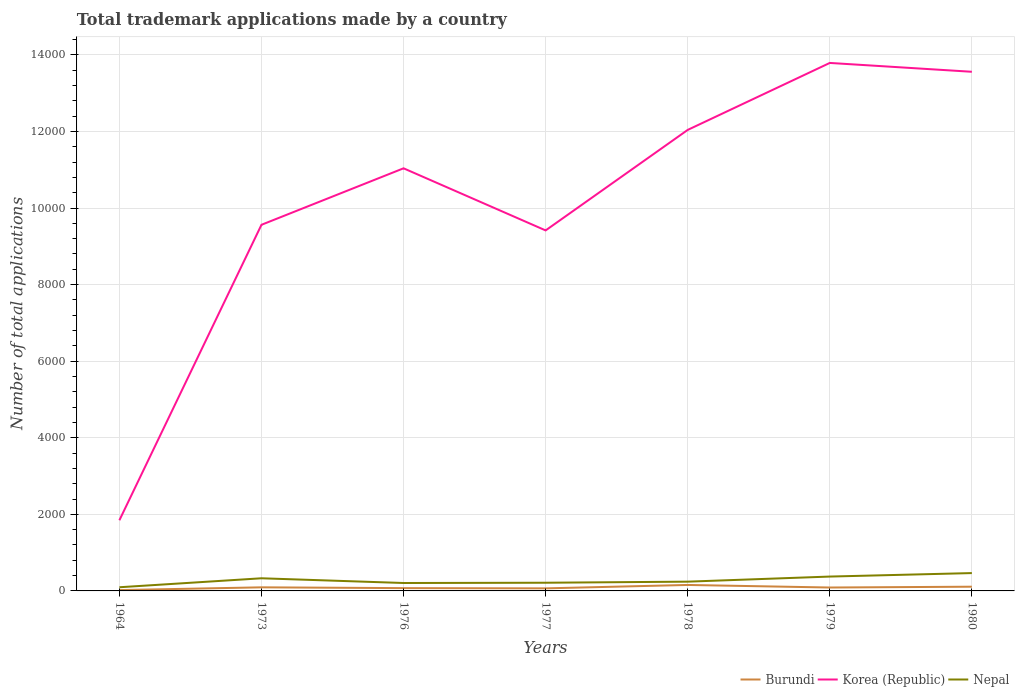How many different coloured lines are there?
Ensure brevity in your answer.  3. Across all years, what is the maximum number of applications made by in Korea (Republic)?
Offer a terse response. 1845. In which year was the number of applications made by in Nepal maximum?
Offer a terse response. 1964. What is the total number of applications made by in Korea (Republic) in the graph?
Give a very brief answer. -2478. What is the difference between the highest and the second highest number of applications made by in Korea (Republic)?
Give a very brief answer. 1.19e+04. What is the difference between the highest and the lowest number of applications made by in Nepal?
Provide a short and direct response. 3. Is the number of applications made by in Nepal strictly greater than the number of applications made by in Burundi over the years?
Provide a succinct answer. No. How many years are there in the graph?
Your answer should be compact. 7. How are the legend labels stacked?
Offer a very short reply. Horizontal. What is the title of the graph?
Give a very brief answer. Total trademark applications made by a country. What is the label or title of the X-axis?
Make the answer very short. Years. What is the label or title of the Y-axis?
Keep it short and to the point. Number of total applications. What is the Number of total applications of Burundi in 1964?
Keep it short and to the point. 22. What is the Number of total applications in Korea (Republic) in 1964?
Keep it short and to the point. 1845. What is the Number of total applications in Nepal in 1964?
Your answer should be compact. 96. What is the Number of total applications in Burundi in 1973?
Make the answer very short. 94. What is the Number of total applications of Korea (Republic) in 1973?
Provide a short and direct response. 9562. What is the Number of total applications in Nepal in 1973?
Provide a short and direct response. 330. What is the Number of total applications in Korea (Republic) in 1976?
Offer a very short reply. 1.10e+04. What is the Number of total applications of Nepal in 1976?
Offer a terse response. 207. What is the Number of total applications of Burundi in 1977?
Provide a short and direct response. 67. What is the Number of total applications of Korea (Republic) in 1977?
Your answer should be very brief. 9415. What is the Number of total applications in Nepal in 1977?
Ensure brevity in your answer.  214. What is the Number of total applications in Burundi in 1978?
Your response must be concise. 156. What is the Number of total applications of Korea (Republic) in 1978?
Provide a short and direct response. 1.20e+04. What is the Number of total applications in Nepal in 1978?
Give a very brief answer. 242. What is the Number of total applications of Burundi in 1979?
Provide a short and direct response. 89. What is the Number of total applications in Korea (Republic) in 1979?
Make the answer very short. 1.38e+04. What is the Number of total applications in Nepal in 1979?
Your answer should be compact. 375. What is the Number of total applications of Burundi in 1980?
Give a very brief answer. 110. What is the Number of total applications of Korea (Republic) in 1980?
Keep it short and to the point. 1.36e+04. What is the Number of total applications in Nepal in 1980?
Ensure brevity in your answer.  466. Across all years, what is the maximum Number of total applications of Burundi?
Your answer should be compact. 156. Across all years, what is the maximum Number of total applications in Korea (Republic)?
Provide a short and direct response. 1.38e+04. Across all years, what is the maximum Number of total applications of Nepal?
Your answer should be very brief. 466. Across all years, what is the minimum Number of total applications in Korea (Republic)?
Make the answer very short. 1845. Across all years, what is the minimum Number of total applications in Nepal?
Keep it short and to the point. 96. What is the total Number of total applications in Burundi in the graph?
Provide a succinct answer. 611. What is the total Number of total applications of Korea (Republic) in the graph?
Your answer should be very brief. 7.12e+04. What is the total Number of total applications of Nepal in the graph?
Provide a succinct answer. 1930. What is the difference between the Number of total applications of Burundi in 1964 and that in 1973?
Your response must be concise. -72. What is the difference between the Number of total applications in Korea (Republic) in 1964 and that in 1973?
Your response must be concise. -7717. What is the difference between the Number of total applications in Nepal in 1964 and that in 1973?
Keep it short and to the point. -234. What is the difference between the Number of total applications in Burundi in 1964 and that in 1976?
Give a very brief answer. -51. What is the difference between the Number of total applications in Korea (Republic) in 1964 and that in 1976?
Provide a short and direct response. -9192. What is the difference between the Number of total applications of Nepal in 1964 and that in 1976?
Your answer should be compact. -111. What is the difference between the Number of total applications in Burundi in 1964 and that in 1977?
Make the answer very short. -45. What is the difference between the Number of total applications in Korea (Republic) in 1964 and that in 1977?
Offer a very short reply. -7570. What is the difference between the Number of total applications of Nepal in 1964 and that in 1977?
Offer a terse response. -118. What is the difference between the Number of total applications of Burundi in 1964 and that in 1978?
Offer a terse response. -134. What is the difference between the Number of total applications in Korea (Republic) in 1964 and that in 1978?
Your answer should be very brief. -1.02e+04. What is the difference between the Number of total applications of Nepal in 1964 and that in 1978?
Your response must be concise. -146. What is the difference between the Number of total applications in Burundi in 1964 and that in 1979?
Provide a short and direct response. -67. What is the difference between the Number of total applications in Korea (Republic) in 1964 and that in 1979?
Your answer should be very brief. -1.19e+04. What is the difference between the Number of total applications of Nepal in 1964 and that in 1979?
Give a very brief answer. -279. What is the difference between the Number of total applications of Burundi in 1964 and that in 1980?
Your answer should be very brief. -88. What is the difference between the Number of total applications of Korea (Republic) in 1964 and that in 1980?
Your answer should be compact. -1.17e+04. What is the difference between the Number of total applications in Nepal in 1964 and that in 1980?
Your answer should be compact. -370. What is the difference between the Number of total applications of Burundi in 1973 and that in 1976?
Offer a terse response. 21. What is the difference between the Number of total applications of Korea (Republic) in 1973 and that in 1976?
Keep it short and to the point. -1475. What is the difference between the Number of total applications in Nepal in 1973 and that in 1976?
Your answer should be compact. 123. What is the difference between the Number of total applications in Korea (Republic) in 1973 and that in 1977?
Give a very brief answer. 147. What is the difference between the Number of total applications in Nepal in 1973 and that in 1977?
Your answer should be compact. 116. What is the difference between the Number of total applications of Burundi in 1973 and that in 1978?
Offer a terse response. -62. What is the difference between the Number of total applications of Korea (Republic) in 1973 and that in 1978?
Your response must be concise. -2478. What is the difference between the Number of total applications in Nepal in 1973 and that in 1978?
Keep it short and to the point. 88. What is the difference between the Number of total applications in Korea (Republic) in 1973 and that in 1979?
Your response must be concise. -4227. What is the difference between the Number of total applications of Nepal in 1973 and that in 1979?
Give a very brief answer. -45. What is the difference between the Number of total applications in Korea (Republic) in 1973 and that in 1980?
Keep it short and to the point. -3996. What is the difference between the Number of total applications in Nepal in 1973 and that in 1980?
Ensure brevity in your answer.  -136. What is the difference between the Number of total applications of Burundi in 1976 and that in 1977?
Make the answer very short. 6. What is the difference between the Number of total applications in Korea (Republic) in 1976 and that in 1977?
Provide a succinct answer. 1622. What is the difference between the Number of total applications of Burundi in 1976 and that in 1978?
Make the answer very short. -83. What is the difference between the Number of total applications in Korea (Republic) in 1976 and that in 1978?
Give a very brief answer. -1003. What is the difference between the Number of total applications in Nepal in 1976 and that in 1978?
Provide a succinct answer. -35. What is the difference between the Number of total applications of Burundi in 1976 and that in 1979?
Your response must be concise. -16. What is the difference between the Number of total applications in Korea (Republic) in 1976 and that in 1979?
Make the answer very short. -2752. What is the difference between the Number of total applications in Nepal in 1976 and that in 1979?
Provide a succinct answer. -168. What is the difference between the Number of total applications in Burundi in 1976 and that in 1980?
Offer a terse response. -37. What is the difference between the Number of total applications in Korea (Republic) in 1976 and that in 1980?
Keep it short and to the point. -2521. What is the difference between the Number of total applications of Nepal in 1976 and that in 1980?
Make the answer very short. -259. What is the difference between the Number of total applications in Burundi in 1977 and that in 1978?
Provide a short and direct response. -89. What is the difference between the Number of total applications of Korea (Republic) in 1977 and that in 1978?
Your answer should be compact. -2625. What is the difference between the Number of total applications in Burundi in 1977 and that in 1979?
Offer a very short reply. -22. What is the difference between the Number of total applications in Korea (Republic) in 1977 and that in 1979?
Your response must be concise. -4374. What is the difference between the Number of total applications in Nepal in 1977 and that in 1979?
Offer a very short reply. -161. What is the difference between the Number of total applications of Burundi in 1977 and that in 1980?
Offer a terse response. -43. What is the difference between the Number of total applications in Korea (Republic) in 1977 and that in 1980?
Provide a short and direct response. -4143. What is the difference between the Number of total applications in Nepal in 1977 and that in 1980?
Your answer should be very brief. -252. What is the difference between the Number of total applications in Burundi in 1978 and that in 1979?
Your response must be concise. 67. What is the difference between the Number of total applications of Korea (Republic) in 1978 and that in 1979?
Your response must be concise. -1749. What is the difference between the Number of total applications in Nepal in 1978 and that in 1979?
Your answer should be very brief. -133. What is the difference between the Number of total applications of Burundi in 1978 and that in 1980?
Offer a terse response. 46. What is the difference between the Number of total applications in Korea (Republic) in 1978 and that in 1980?
Give a very brief answer. -1518. What is the difference between the Number of total applications of Nepal in 1978 and that in 1980?
Your response must be concise. -224. What is the difference between the Number of total applications of Burundi in 1979 and that in 1980?
Your answer should be very brief. -21. What is the difference between the Number of total applications of Korea (Republic) in 1979 and that in 1980?
Your answer should be compact. 231. What is the difference between the Number of total applications in Nepal in 1979 and that in 1980?
Give a very brief answer. -91. What is the difference between the Number of total applications in Burundi in 1964 and the Number of total applications in Korea (Republic) in 1973?
Your answer should be very brief. -9540. What is the difference between the Number of total applications in Burundi in 1964 and the Number of total applications in Nepal in 1973?
Your answer should be very brief. -308. What is the difference between the Number of total applications in Korea (Republic) in 1964 and the Number of total applications in Nepal in 1973?
Your response must be concise. 1515. What is the difference between the Number of total applications of Burundi in 1964 and the Number of total applications of Korea (Republic) in 1976?
Keep it short and to the point. -1.10e+04. What is the difference between the Number of total applications of Burundi in 1964 and the Number of total applications of Nepal in 1976?
Make the answer very short. -185. What is the difference between the Number of total applications in Korea (Republic) in 1964 and the Number of total applications in Nepal in 1976?
Make the answer very short. 1638. What is the difference between the Number of total applications of Burundi in 1964 and the Number of total applications of Korea (Republic) in 1977?
Offer a very short reply. -9393. What is the difference between the Number of total applications in Burundi in 1964 and the Number of total applications in Nepal in 1977?
Your answer should be compact. -192. What is the difference between the Number of total applications of Korea (Republic) in 1964 and the Number of total applications of Nepal in 1977?
Your answer should be very brief. 1631. What is the difference between the Number of total applications in Burundi in 1964 and the Number of total applications in Korea (Republic) in 1978?
Your answer should be compact. -1.20e+04. What is the difference between the Number of total applications in Burundi in 1964 and the Number of total applications in Nepal in 1978?
Provide a succinct answer. -220. What is the difference between the Number of total applications in Korea (Republic) in 1964 and the Number of total applications in Nepal in 1978?
Provide a succinct answer. 1603. What is the difference between the Number of total applications of Burundi in 1964 and the Number of total applications of Korea (Republic) in 1979?
Make the answer very short. -1.38e+04. What is the difference between the Number of total applications in Burundi in 1964 and the Number of total applications in Nepal in 1979?
Offer a very short reply. -353. What is the difference between the Number of total applications of Korea (Republic) in 1964 and the Number of total applications of Nepal in 1979?
Ensure brevity in your answer.  1470. What is the difference between the Number of total applications of Burundi in 1964 and the Number of total applications of Korea (Republic) in 1980?
Your answer should be very brief. -1.35e+04. What is the difference between the Number of total applications of Burundi in 1964 and the Number of total applications of Nepal in 1980?
Your response must be concise. -444. What is the difference between the Number of total applications in Korea (Republic) in 1964 and the Number of total applications in Nepal in 1980?
Provide a short and direct response. 1379. What is the difference between the Number of total applications of Burundi in 1973 and the Number of total applications of Korea (Republic) in 1976?
Keep it short and to the point. -1.09e+04. What is the difference between the Number of total applications in Burundi in 1973 and the Number of total applications in Nepal in 1976?
Provide a succinct answer. -113. What is the difference between the Number of total applications of Korea (Republic) in 1973 and the Number of total applications of Nepal in 1976?
Your answer should be compact. 9355. What is the difference between the Number of total applications of Burundi in 1973 and the Number of total applications of Korea (Republic) in 1977?
Your answer should be very brief. -9321. What is the difference between the Number of total applications in Burundi in 1973 and the Number of total applications in Nepal in 1977?
Your answer should be compact. -120. What is the difference between the Number of total applications of Korea (Republic) in 1973 and the Number of total applications of Nepal in 1977?
Provide a short and direct response. 9348. What is the difference between the Number of total applications in Burundi in 1973 and the Number of total applications in Korea (Republic) in 1978?
Your answer should be compact. -1.19e+04. What is the difference between the Number of total applications of Burundi in 1973 and the Number of total applications of Nepal in 1978?
Provide a succinct answer. -148. What is the difference between the Number of total applications in Korea (Republic) in 1973 and the Number of total applications in Nepal in 1978?
Provide a succinct answer. 9320. What is the difference between the Number of total applications in Burundi in 1973 and the Number of total applications in Korea (Republic) in 1979?
Your answer should be very brief. -1.37e+04. What is the difference between the Number of total applications in Burundi in 1973 and the Number of total applications in Nepal in 1979?
Your response must be concise. -281. What is the difference between the Number of total applications in Korea (Republic) in 1973 and the Number of total applications in Nepal in 1979?
Ensure brevity in your answer.  9187. What is the difference between the Number of total applications in Burundi in 1973 and the Number of total applications in Korea (Republic) in 1980?
Ensure brevity in your answer.  -1.35e+04. What is the difference between the Number of total applications of Burundi in 1973 and the Number of total applications of Nepal in 1980?
Ensure brevity in your answer.  -372. What is the difference between the Number of total applications of Korea (Republic) in 1973 and the Number of total applications of Nepal in 1980?
Make the answer very short. 9096. What is the difference between the Number of total applications in Burundi in 1976 and the Number of total applications in Korea (Republic) in 1977?
Provide a succinct answer. -9342. What is the difference between the Number of total applications in Burundi in 1976 and the Number of total applications in Nepal in 1977?
Your answer should be very brief. -141. What is the difference between the Number of total applications in Korea (Republic) in 1976 and the Number of total applications in Nepal in 1977?
Give a very brief answer. 1.08e+04. What is the difference between the Number of total applications of Burundi in 1976 and the Number of total applications of Korea (Republic) in 1978?
Provide a succinct answer. -1.20e+04. What is the difference between the Number of total applications in Burundi in 1976 and the Number of total applications in Nepal in 1978?
Provide a succinct answer. -169. What is the difference between the Number of total applications of Korea (Republic) in 1976 and the Number of total applications of Nepal in 1978?
Give a very brief answer. 1.08e+04. What is the difference between the Number of total applications of Burundi in 1976 and the Number of total applications of Korea (Republic) in 1979?
Keep it short and to the point. -1.37e+04. What is the difference between the Number of total applications of Burundi in 1976 and the Number of total applications of Nepal in 1979?
Provide a succinct answer. -302. What is the difference between the Number of total applications of Korea (Republic) in 1976 and the Number of total applications of Nepal in 1979?
Offer a very short reply. 1.07e+04. What is the difference between the Number of total applications of Burundi in 1976 and the Number of total applications of Korea (Republic) in 1980?
Your answer should be compact. -1.35e+04. What is the difference between the Number of total applications in Burundi in 1976 and the Number of total applications in Nepal in 1980?
Make the answer very short. -393. What is the difference between the Number of total applications in Korea (Republic) in 1976 and the Number of total applications in Nepal in 1980?
Provide a succinct answer. 1.06e+04. What is the difference between the Number of total applications in Burundi in 1977 and the Number of total applications in Korea (Republic) in 1978?
Your response must be concise. -1.20e+04. What is the difference between the Number of total applications in Burundi in 1977 and the Number of total applications in Nepal in 1978?
Your response must be concise. -175. What is the difference between the Number of total applications in Korea (Republic) in 1977 and the Number of total applications in Nepal in 1978?
Offer a terse response. 9173. What is the difference between the Number of total applications in Burundi in 1977 and the Number of total applications in Korea (Republic) in 1979?
Make the answer very short. -1.37e+04. What is the difference between the Number of total applications in Burundi in 1977 and the Number of total applications in Nepal in 1979?
Your response must be concise. -308. What is the difference between the Number of total applications in Korea (Republic) in 1977 and the Number of total applications in Nepal in 1979?
Give a very brief answer. 9040. What is the difference between the Number of total applications in Burundi in 1977 and the Number of total applications in Korea (Republic) in 1980?
Offer a very short reply. -1.35e+04. What is the difference between the Number of total applications in Burundi in 1977 and the Number of total applications in Nepal in 1980?
Give a very brief answer. -399. What is the difference between the Number of total applications of Korea (Republic) in 1977 and the Number of total applications of Nepal in 1980?
Offer a terse response. 8949. What is the difference between the Number of total applications in Burundi in 1978 and the Number of total applications in Korea (Republic) in 1979?
Ensure brevity in your answer.  -1.36e+04. What is the difference between the Number of total applications of Burundi in 1978 and the Number of total applications of Nepal in 1979?
Your response must be concise. -219. What is the difference between the Number of total applications of Korea (Republic) in 1978 and the Number of total applications of Nepal in 1979?
Give a very brief answer. 1.17e+04. What is the difference between the Number of total applications in Burundi in 1978 and the Number of total applications in Korea (Republic) in 1980?
Your answer should be very brief. -1.34e+04. What is the difference between the Number of total applications in Burundi in 1978 and the Number of total applications in Nepal in 1980?
Your answer should be very brief. -310. What is the difference between the Number of total applications in Korea (Republic) in 1978 and the Number of total applications in Nepal in 1980?
Your answer should be very brief. 1.16e+04. What is the difference between the Number of total applications of Burundi in 1979 and the Number of total applications of Korea (Republic) in 1980?
Keep it short and to the point. -1.35e+04. What is the difference between the Number of total applications in Burundi in 1979 and the Number of total applications in Nepal in 1980?
Offer a very short reply. -377. What is the difference between the Number of total applications of Korea (Republic) in 1979 and the Number of total applications of Nepal in 1980?
Ensure brevity in your answer.  1.33e+04. What is the average Number of total applications in Burundi per year?
Your response must be concise. 87.29. What is the average Number of total applications of Korea (Republic) per year?
Your answer should be compact. 1.02e+04. What is the average Number of total applications of Nepal per year?
Your response must be concise. 275.71. In the year 1964, what is the difference between the Number of total applications of Burundi and Number of total applications of Korea (Republic)?
Your answer should be very brief. -1823. In the year 1964, what is the difference between the Number of total applications in Burundi and Number of total applications in Nepal?
Make the answer very short. -74. In the year 1964, what is the difference between the Number of total applications of Korea (Republic) and Number of total applications of Nepal?
Your answer should be very brief. 1749. In the year 1973, what is the difference between the Number of total applications in Burundi and Number of total applications in Korea (Republic)?
Provide a short and direct response. -9468. In the year 1973, what is the difference between the Number of total applications of Burundi and Number of total applications of Nepal?
Provide a short and direct response. -236. In the year 1973, what is the difference between the Number of total applications of Korea (Republic) and Number of total applications of Nepal?
Ensure brevity in your answer.  9232. In the year 1976, what is the difference between the Number of total applications in Burundi and Number of total applications in Korea (Republic)?
Provide a succinct answer. -1.10e+04. In the year 1976, what is the difference between the Number of total applications of Burundi and Number of total applications of Nepal?
Keep it short and to the point. -134. In the year 1976, what is the difference between the Number of total applications of Korea (Republic) and Number of total applications of Nepal?
Your answer should be very brief. 1.08e+04. In the year 1977, what is the difference between the Number of total applications in Burundi and Number of total applications in Korea (Republic)?
Give a very brief answer. -9348. In the year 1977, what is the difference between the Number of total applications of Burundi and Number of total applications of Nepal?
Your answer should be compact. -147. In the year 1977, what is the difference between the Number of total applications of Korea (Republic) and Number of total applications of Nepal?
Provide a succinct answer. 9201. In the year 1978, what is the difference between the Number of total applications of Burundi and Number of total applications of Korea (Republic)?
Your answer should be compact. -1.19e+04. In the year 1978, what is the difference between the Number of total applications in Burundi and Number of total applications in Nepal?
Provide a short and direct response. -86. In the year 1978, what is the difference between the Number of total applications in Korea (Republic) and Number of total applications in Nepal?
Give a very brief answer. 1.18e+04. In the year 1979, what is the difference between the Number of total applications of Burundi and Number of total applications of Korea (Republic)?
Your response must be concise. -1.37e+04. In the year 1979, what is the difference between the Number of total applications in Burundi and Number of total applications in Nepal?
Your answer should be very brief. -286. In the year 1979, what is the difference between the Number of total applications in Korea (Republic) and Number of total applications in Nepal?
Your answer should be compact. 1.34e+04. In the year 1980, what is the difference between the Number of total applications in Burundi and Number of total applications in Korea (Republic)?
Give a very brief answer. -1.34e+04. In the year 1980, what is the difference between the Number of total applications of Burundi and Number of total applications of Nepal?
Provide a succinct answer. -356. In the year 1980, what is the difference between the Number of total applications of Korea (Republic) and Number of total applications of Nepal?
Make the answer very short. 1.31e+04. What is the ratio of the Number of total applications in Burundi in 1964 to that in 1973?
Ensure brevity in your answer.  0.23. What is the ratio of the Number of total applications in Korea (Republic) in 1964 to that in 1973?
Your answer should be compact. 0.19. What is the ratio of the Number of total applications in Nepal in 1964 to that in 1973?
Your answer should be very brief. 0.29. What is the ratio of the Number of total applications of Burundi in 1964 to that in 1976?
Offer a terse response. 0.3. What is the ratio of the Number of total applications in Korea (Republic) in 1964 to that in 1976?
Give a very brief answer. 0.17. What is the ratio of the Number of total applications of Nepal in 1964 to that in 1976?
Your answer should be very brief. 0.46. What is the ratio of the Number of total applications in Burundi in 1964 to that in 1977?
Your answer should be very brief. 0.33. What is the ratio of the Number of total applications in Korea (Republic) in 1964 to that in 1977?
Make the answer very short. 0.2. What is the ratio of the Number of total applications in Nepal in 1964 to that in 1977?
Your response must be concise. 0.45. What is the ratio of the Number of total applications of Burundi in 1964 to that in 1978?
Provide a succinct answer. 0.14. What is the ratio of the Number of total applications in Korea (Republic) in 1964 to that in 1978?
Your answer should be very brief. 0.15. What is the ratio of the Number of total applications of Nepal in 1964 to that in 1978?
Keep it short and to the point. 0.4. What is the ratio of the Number of total applications in Burundi in 1964 to that in 1979?
Your response must be concise. 0.25. What is the ratio of the Number of total applications of Korea (Republic) in 1964 to that in 1979?
Offer a terse response. 0.13. What is the ratio of the Number of total applications of Nepal in 1964 to that in 1979?
Provide a short and direct response. 0.26. What is the ratio of the Number of total applications of Korea (Republic) in 1964 to that in 1980?
Your answer should be very brief. 0.14. What is the ratio of the Number of total applications in Nepal in 1964 to that in 1980?
Provide a short and direct response. 0.21. What is the ratio of the Number of total applications of Burundi in 1973 to that in 1976?
Offer a terse response. 1.29. What is the ratio of the Number of total applications in Korea (Republic) in 1973 to that in 1976?
Offer a terse response. 0.87. What is the ratio of the Number of total applications of Nepal in 1973 to that in 1976?
Ensure brevity in your answer.  1.59. What is the ratio of the Number of total applications in Burundi in 1973 to that in 1977?
Your response must be concise. 1.4. What is the ratio of the Number of total applications of Korea (Republic) in 1973 to that in 1977?
Make the answer very short. 1.02. What is the ratio of the Number of total applications of Nepal in 1973 to that in 1977?
Your answer should be compact. 1.54. What is the ratio of the Number of total applications of Burundi in 1973 to that in 1978?
Offer a terse response. 0.6. What is the ratio of the Number of total applications of Korea (Republic) in 1973 to that in 1978?
Offer a very short reply. 0.79. What is the ratio of the Number of total applications in Nepal in 1973 to that in 1978?
Provide a succinct answer. 1.36. What is the ratio of the Number of total applications of Burundi in 1973 to that in 1979?
Your response must be concise. 1.06. What is the ratio of the Number of total applications of Korea (Republic) in 1973 to that in 1979?
Your answer should be very brief. 0.69. What is the ratio of the Number of total applications in Nepal in 1973 to that in 1979?
Offer a very short reply. 0.88. What is the ratio of the Number of total applications in Burundi in 1973 to that in 1980?
Your response must be concise. 0.85. What is the ratio of the Number of total applications of Korea (Republic) in 1973 to that in 1980?
Make the answer very short. 0.71. What is the ratio of the Number of total applications in Nepal in 1973 to that in 1980?
Provide a succinct answer. 0.71. What is the ratio of the Number of total applications in Burundi in 1976 to that in 1977?
Your answer should be compact. 1.09. What is the ratio of the Number of total applications in Korea (Republic) in 1976 to that in 1977?
Provide a succinct answer. 1.17. What is the ratio of the Number of total applications of Nepal in 1976 to that in 1977?
Your answer should be very brief. 0.97. What is the ratio of the Number of total applications of Burundi in 1976 to that in 1978?
Keep it short and to the point. 0.47. What is the ratio of the Number of total applications in Korea (Republic) in 1976 to that in 1978?
Provide a succinct answer. 0.92. What is the ratio of the Number of total applications of Nepal in 1976 to that in 1978?
Your answer should be compact. 0.86. What is the ratio of the Number of total applications of Burundi in 1976 to that in 1979?
Make the answer very short. 0.82. What is the ratio of the Number of total applications in Korea (Republic) in 1976 to that in 1979?
Your response must be concise. 0.8. What is the ratio of the Number of total applications in Nepal in 1976 to that in 1979?
Ensure brevity in your answer.  0.55. What is the ratio of the Number of total applications in Burundi in 1976 to that in 1980?
Your answer should be very brief. 0.66. What is the ratio of the Number of total applications of Korea (Republic) in 1976 to that in 1980?
Give a very brief answer. 0.81. What is the ratio of the Number of total applications in Nepal in 1976 to that in 1980?
Make the answer very short. 0.44. What is the ratio of the Number of total applications in Burundi in 1977 to that in 1978?
Your answer should be compact. 0.43. What is the ratio of the Number of total applications of Korea (Republic) in 1977 to that in 1978?
Ensure brevity in your answer.  0.78. What is the ratio of the Number of total applications in Nepal in 1977 to that in 1978?
Make the answer very short. 0.88. What is the ratio of the Number of total applications of Burundi in 1977 to that in 1979?
Keep it short and to the point. 0.75. What is the ratio of the Number of total applications of Korea (Republic) in 1977 to that in 1979?
Offer a terse response. 0.68. What is the ratio of the Number of total applications in Nepal in 1977 to that in 1979?
Your answer should be compact. 0.57. What is the ratio of the Number of total applications in Burundi in 1977 to that in 1980?
Provide a short and direct response. 0.61. What is the ratio of the Number of total applications in Korea (Republic) in 1977 to that in 1980?
Offer a very short reply. 0.69. What is the ratio of the Number of total applications of Nepal in 1977 to that in 1980?
Your answer should be compact. 0.46. What is the ratio of the Number of total applications of Burundi in 1978 to that in 1979?
Offer a very short reply. 1.75. What is the ratio of the Number of total applications in Korea (Republic) in 1978 to that in 1979?
Provide a short and direct response. 0.87. What is the ratio of the Number of total applications of Nepal in 1978 to that in 1979?
Make the answer very short. 0.65. What is the ratio of the Number of total applications in Burundi in 1978 to that in 1980?
Your answer should be compact. 1.42. What is the ratio of the Number of total applications of Korea (Republic) in 1978 to that in 1980?
Ensure brevity in your answer.  0.89. What is the ratio of the Number of total applications of Nepal in 1978 to that in 1980?
Your response must be concise. 0.52. What is the ratio of the Number of total applications in Burundi in 1979 to that in 1980?
Offer a terse response. 0.81. What is the ratio of the Number of total applications in Nepal in 1979 to that in 1980?
Give a very brief answer. 0.8. What is the difference between the highest and the second highest Number of total applications of Burundi?
Your answer should be compact. 46. What is the difference between the highest and the second highest Number of total applications in Korea (Republic)?
Give a very brief answer. 231. What is the difference between the highest and the second highest Number of total applications of Nepal?
Your response must be concise. 91. What is the difference between the highest and the lowest Number of total applications in Burundi?
Your answer should be very brief. 134. What is the difference between the highest and the lowest Number of total applications in Korea (Republic)?
Keep it short and to the point. 1.19e+04. What is the difference between the highest and the lowest Number of total applications in Nepal?
Provide a short and direct response. 370. 